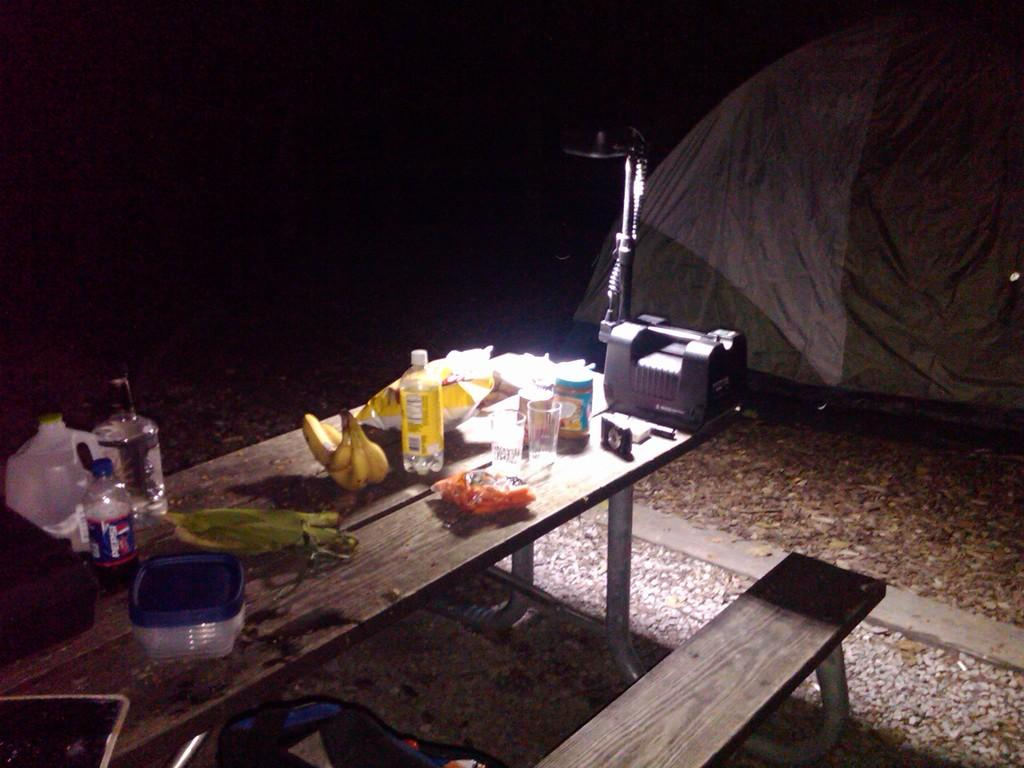What type of furniture is in the image? There is a bench in the image. What objects are on the table in the image? There is a box, a bottle, a banana, a glass, and a light on the table in the image. Can you describe the cover tent in the image? There is a cover tent at the back side of the image. Who is the creator of the shade in the image? There is no shade present in the image, so it is not possible to determine the creator. Can you tell me how many toads are sitting on the bench in the image? There are no toads present in the image; only a bench, a table, and various objects on the table are visible. 